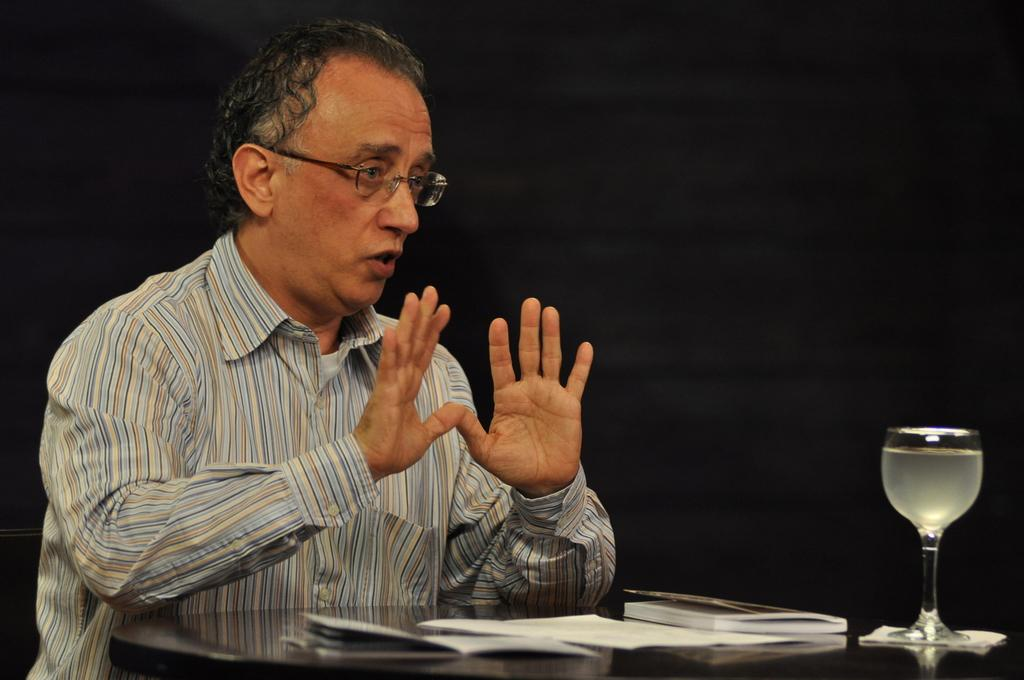Who or what is in the image? There is a person in the image. What is in front of the person? There is a table in front of the person. What can be seen on the table? There is a glass of drink, a book, and papers on the table. What is the lighting condition in the image? The background of the image is dark. What type of watch is the person wearing in the image? There is no watch visible on the person in the image. What is the air quality like in the image? The provided facts do not mention anything about the air quality in the image. 